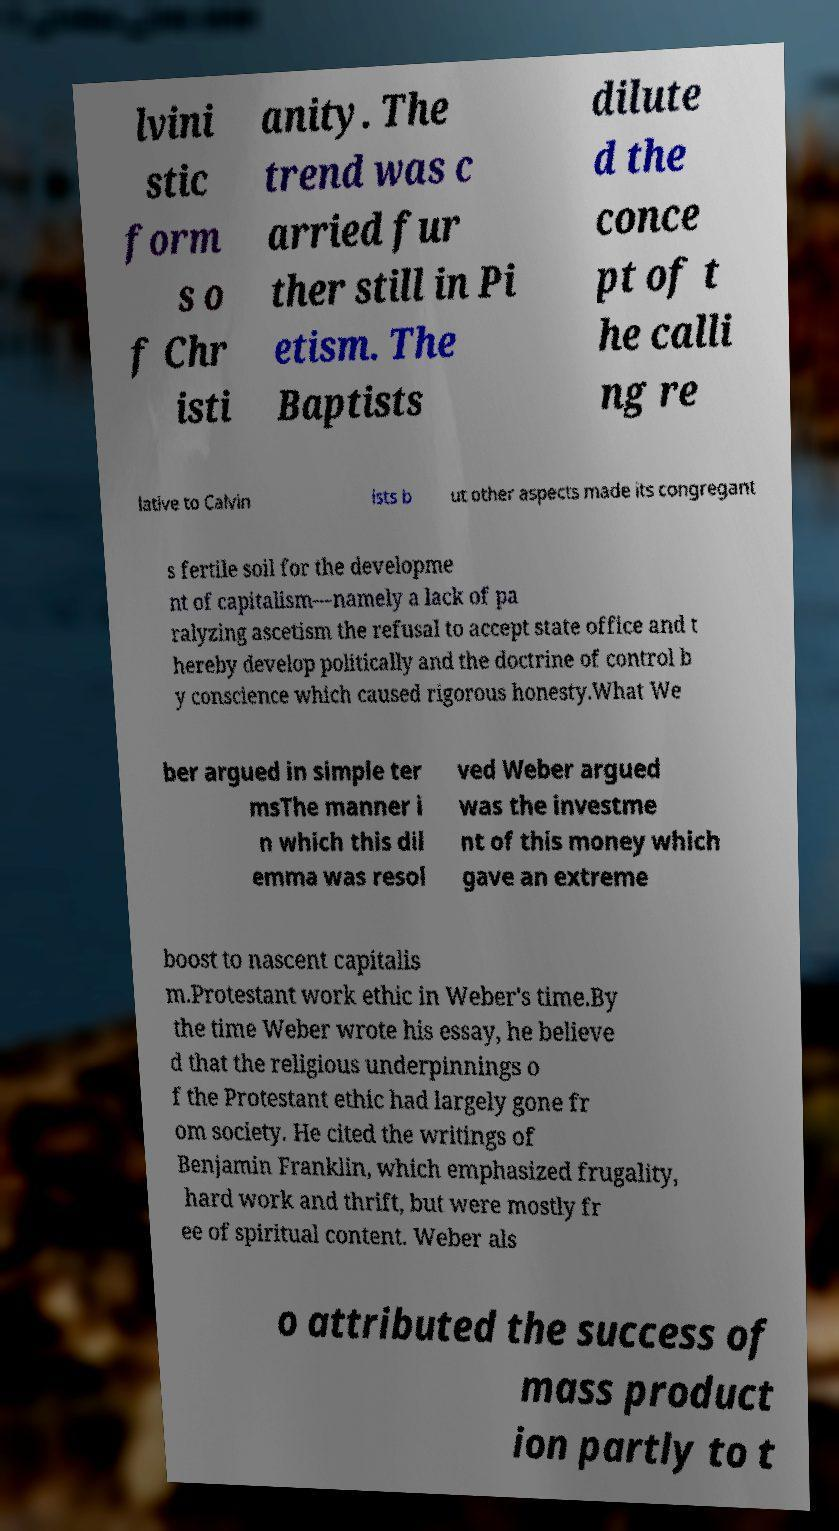Can you accurately transcribe the text from the provided image for me? lvini stic form s o f Chr isti anity. The trend was c arried fur ther still in Pi etism. The Baptists dilute d the conce pt of t he calli ng re lative to Calvin ists b ut other aspects made its congregant s fertile soil for the developme nt of capitalism—namely a lack of pa ralyzing ascetism the refusal to accept state office and t hereby develop politically and the doctrine of control b y conscience which caused rigorous honesty.What We ber argued in simple ter msThe manner i n which this dil emma was resol ved Weber argued was the investme nt of this money which gave an extreme boost to nascent capitalis m.Protestant work ethic in Weber's time.By the time Weber wrote his essay, he believe d that the religious underpinnings o f the Protestant ethic had largely gone fr om society. He cited the writings of Benjamin Franklin, which emphasized frugality, hard work and thrift, but were mostly fr ee of spiritual content. Weber als o attributed the success of mass product ion partly to t 